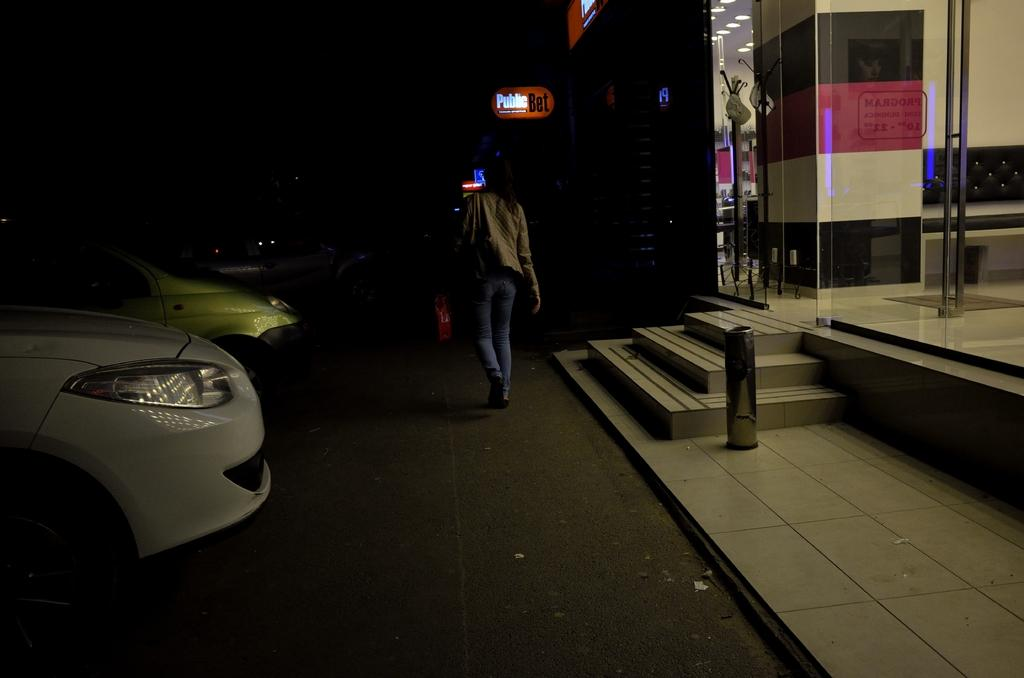What is the main subject of the image? There is a person walking on the road in the image. What else can be seen in the image besides the person walking? There are vehicles, boards, lights, a ceiling, a glass door, and a pillar in the image. Can you describe the vehicles in the image? The provided facts do not specify the type or number of vehicles in the image. What is the purpose of the boards in the image? The provided facts do not specify the purpose or content of the boards in the image. What type of toy is the queen holding in the image? There is no queen or toy present in the image. What drink is the person walking on the road holding in the image? The provided facts do not mention any drinks or beverages in the image. 